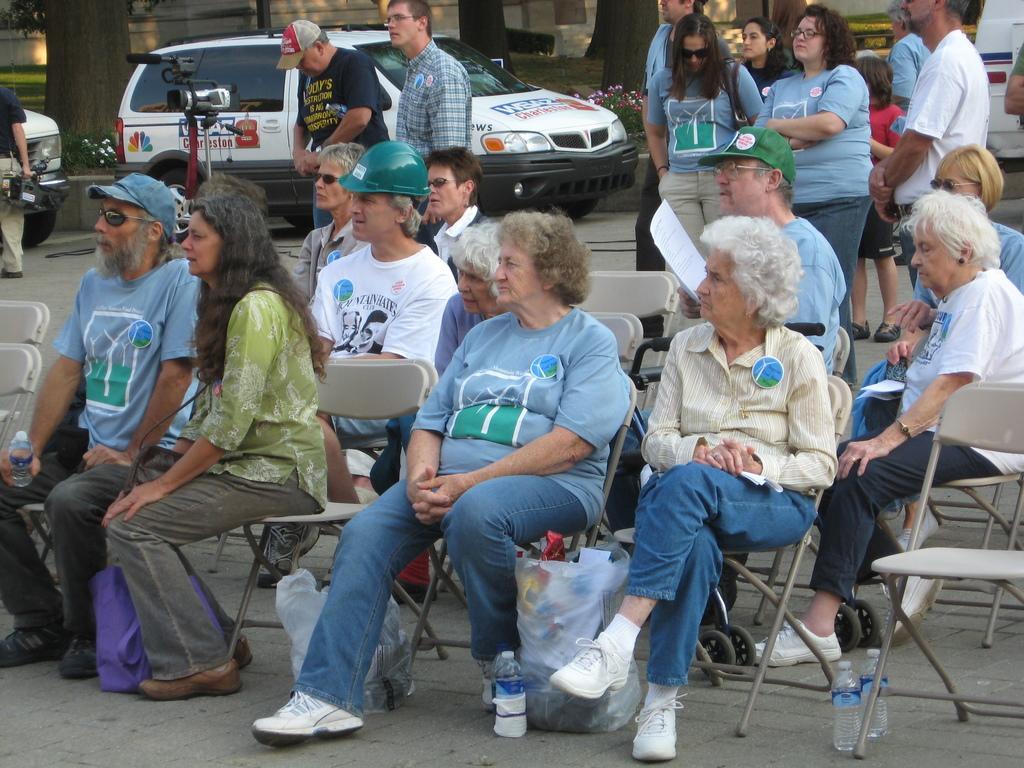Could you give a brief overview of what you see in this image? There are many people sitting in the chairs. Some are wearing caps and some are wearing helmets. There are men and women here. In the background some of them are standing. There is a vehicle parked here. Here is a camera. 